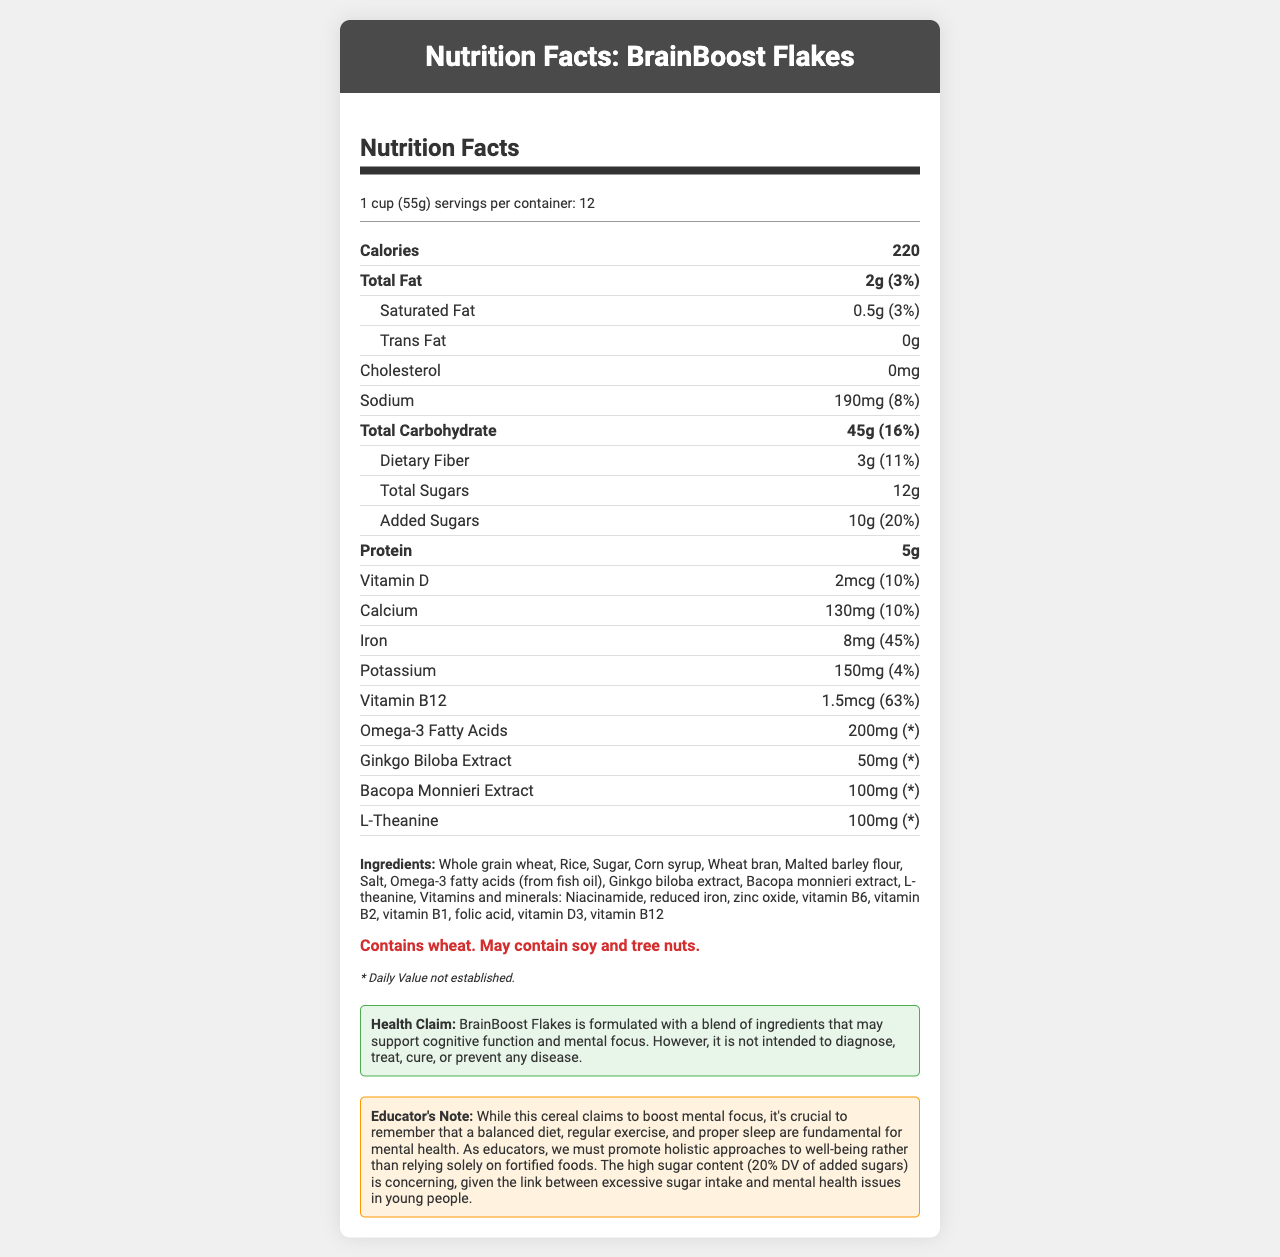what is the serving size for BrainBoost Flakes? The serving size is listed directly under the product name and indicated as "1 cup (55g)".
Answer: 1 cup (55g) how many servings are in one container of BrainBoost Flakes? The number of servings per container is clearly stated as 12 in the serving information section.
Answer: 12 how much added sugar does one serving contain? Under the total carbohydrate section, it mentions "Added Sugars: 10g (20% DV)".
Answer: 10g what is the percentage daily value of Vitamin B12 per serving? The information about Vitamin B12 states a daily value percentage of 63%.
Answer: 63% are there any allergen warnings for BrainBoost Flakes? The allergen information mentions "Contains wheat. May contain soy and tree nuts."
Answer: Yes what ingredients are listed in BrainBoost Flakes? The ingredients are listed in the section marked "Ingredients".
Answer: Whole grain wheat, Rice, Sugar, Corn syrup, Wheat bran, Malted barley flour, Salt, Omega-3 fatty acids (from fish oil), Ginkgo biloba extract, Bacopa monnieri extract, L-theanine, Vitamins and minerals: Niacinamide, reduced iron, zinc oxide, vitamin B6, vitamin B2, vitamin B1, folic acid, vitamin D3, vitamin B12 what is the main claim made by the health claim section? The health claim states that BrainBoost Flakes is formulated with a blend of ingredients that may support cognitive function and mental focus.
Answer: May support cognitive function and mental focus what is the calorie content per serving? The number of calories per serving is listed directly in the nutrition facts section.
Answer: 220 calories how much iron is in one serving of BrainBoost Flakes? It is specified in the nutrients section that each serving contains 8mg of iron.
Answer: 8mg how can BrainBoost Flakes help with mental health? A. By lowering sugar intake B. By providing Omega-3 fatty acids C. By reducing fat consumption The information highlights that Omega-3 fatty acids are among the ingredients, which are often linked to cognitive benefits.
Answer: B. By providing Omega-3 fatty acids which of the following statements is true? A. BrainBoost Flakes contain high amounts of trans fat B. BrainBoost Flakes are devoid of Vitamin D C. BrainBoost Flakes contain L-theanine to aid mental focus The nutrition facts list L-theanine as one ingredient aimed at boosting mental focus.
Answer: C does the product contain cholesterol? The nutrition facts list cholesterol as 0mg per serving.
Answer: No summarize the main idea of the document. The document provides an overview of the nutritional contents and functional ingredients of BrainBoost Flakes, emphasizing its focus on cognitive support while noting the presence of added sugars and allergens. The educator note stresses the importance of a balanced lifestyle beyond just consuming fortified foods.
Answer: BrainBoost Flakes is a fortified breakfast cereal designed to support cognitive function and mental focus, containing ingredients like Omega-3 fatty acids, Ginkgo biloba, and L-theanine. The product highlights its nutritional content and daily values for various components but warns about its high sugar content and potential allergens. how does the added sugar content in BrainBoost Flakes impact mental health? The document mentions the added sugar content (10g, 20% DV) and links between high sugar intake and mental health issues but does not provide detailed specifics on the impact.
Answer: Not enough information what daily value percentage of Omega-3 Fatty Acids is established for the product? The disclaimer states that the daily value for Omega-3 Fatty Acids is not established.
Answer: Cannot be determined 